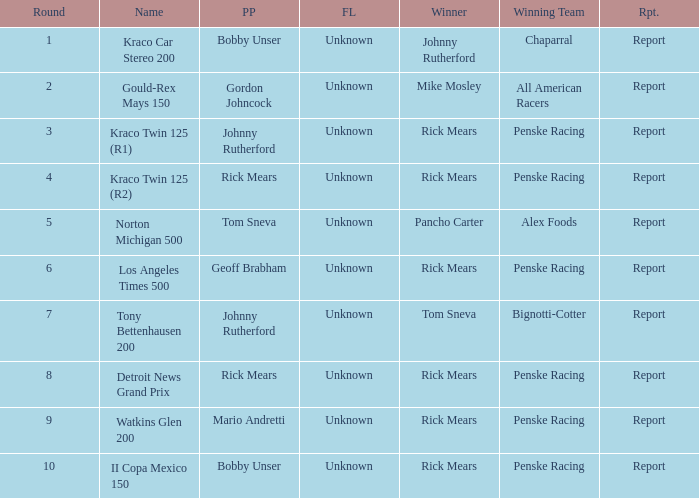What are the races that johnny rutherford has won? Kraco Car Stereo 200. 